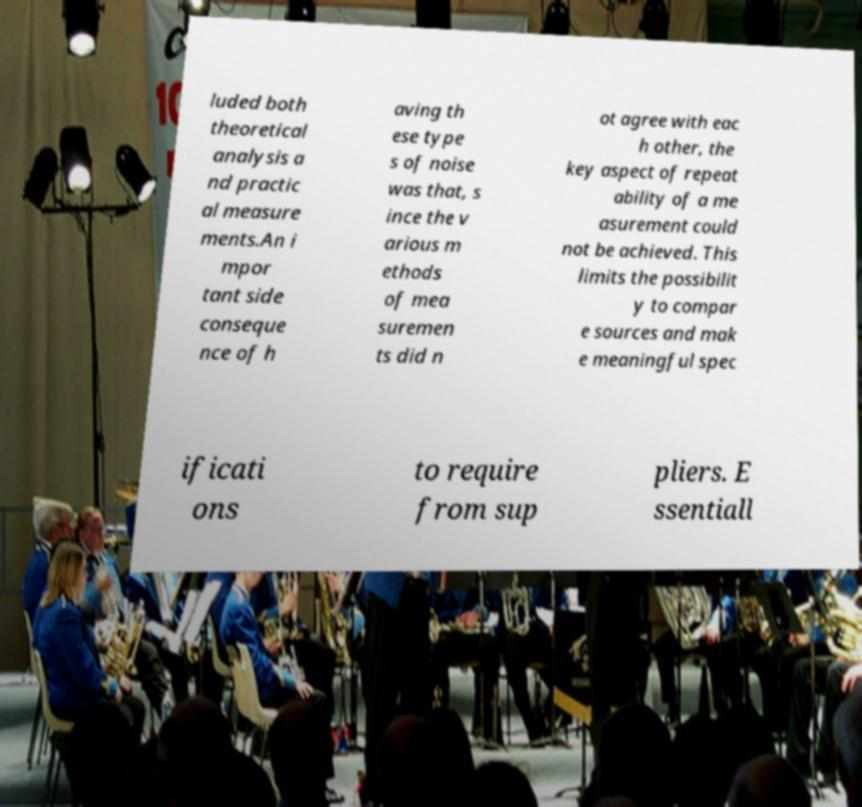Please identify and transcribe the text found in this image. luded both theoretical analysis a nd practic al measure ments.An i mpor tant side conseque nce of h aving th ese type s of noise was that, s ince the v arious m ethods of mea suremen ts did n ot agree with eac h other, the key aspect of repeat ability of a me asurement could not be achieved. This limits the possibilit y to compar e sources and mak e meaningful spec ificati ons to require from sup pliers. E ssentiall 